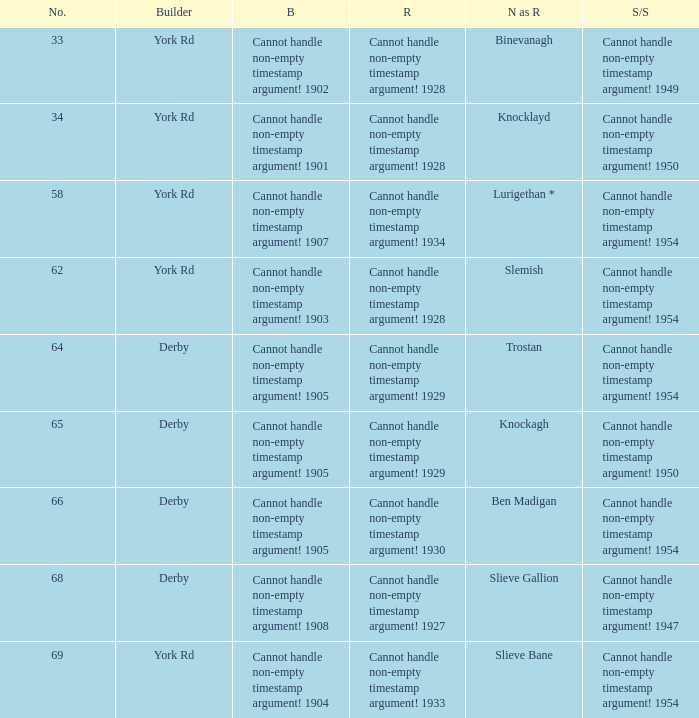Which Rebuilt has a Builder of derby, and a Name as rebuilt of ben madigan? Cannot handle non-empty timestamp argument! 1930. 